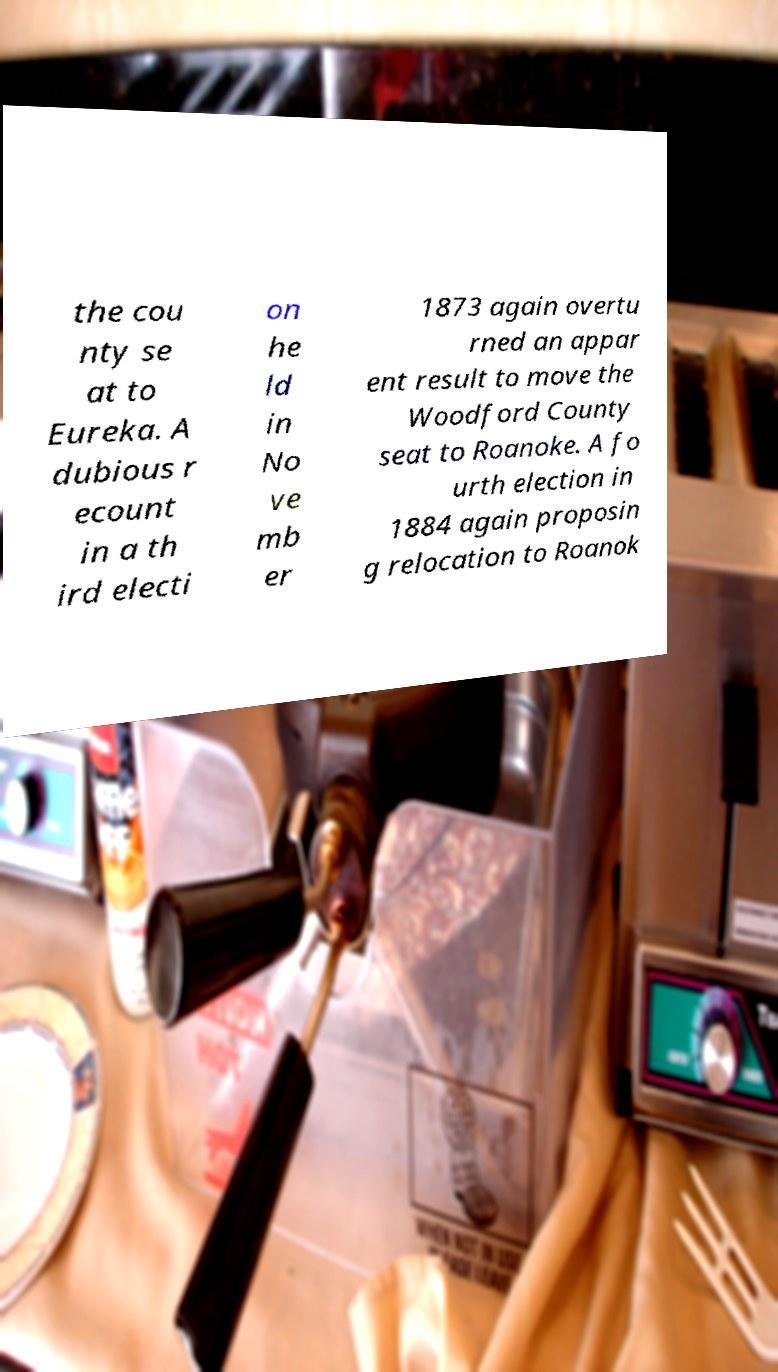I need the written content from this picture converted into text. Can you do that? the cou nty se at to Eureka. A dubious r ecount in a th ird electi on he ld in No ve mb er 1873 again overtu rned an appar ent result to move the Woodford County seat to Roanoke. A fo urth election in 1884 again proposin g relocation to Roanok 